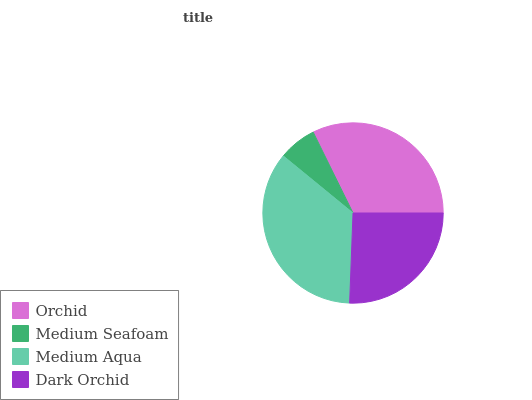Is Medium Seafoam the minimum?
Answer yes or no. Yes. Is Medium Aqua the maximum?
Answer yes or no. Yes. Is Medium Aqua the minimum?
Answer yes or no. No. Is Medium Seafoam the maximum?
Answer yes or no. No. Is Medium Aqua greater than Medium Seafoam?
Answer yes or no. Yes. Is Medium Seafoam less than Medium Aqua?
Answer yes or no. Yes. Is Medium Seafoam greater than Medium Aqua?
Answer yes or no. No. Is Medium Aqua less than Medium Seafoam?
Answer yes or no. No. Is Orchid the high median?
Answer yes or no. Yes. Is Dark Orchid the low median?
Answer yes or no. Yes. Is Medium Seafoam the high median?
Answer yes or no. No. Is Medium Seafoam the low median?
Answer yes or no. No. 